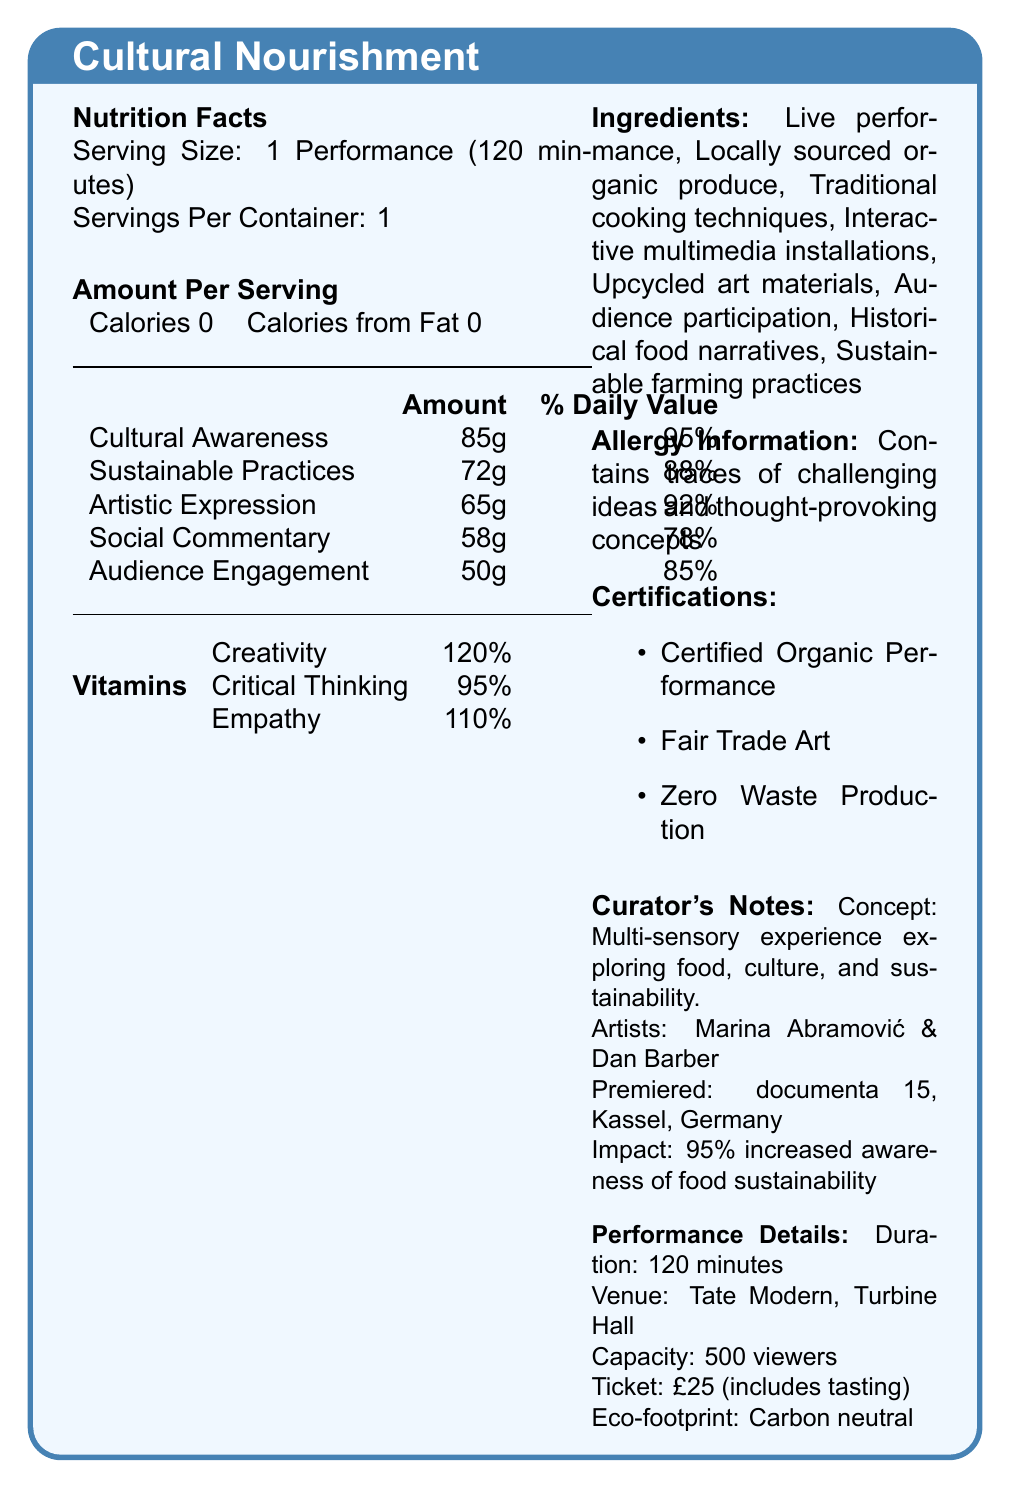what is the serving size? The serving size is specifically mentioned as "1 Performance (120 minutes)" in the document.
Answer: 1 Performance (120 minutes) how many servings are there per container? The document indicates that there is 1 serving per container.
Answer: 1 how many calories are in each serving? Each serving contains 0 calories, as stated in the "Amount Per Serving" section.
Answer: 0 what is the daily value percentage of Cultural Awareness? The daily value percentage of Cultural Awareness is given as 95%.
Answer: 95% which vitamin has the highest daily value percentage? Creativity has the highest daily value percentage at 120%, as listed in the vitamins section.
Answer: Creativity which nutrient contributes the least to the daily value percentage? A. Cultural Awareness B. Social Commentary C. Artistic Expression D. Audience Engagement Social Commentary contributes the least to the daily value percentage with 78%.
Answer: B. Social Commentary what is included in the ticket price? A. Viewing the performance B. Tasting experience C. Behind-the-scenes tour D. Free merchandise The ticket price of £25 includes a tasting experience.
Answer: B. Tasting experience is the performance event carbon neutral? The document specifies that the event is carbon-neutral under the performance details section.
Answer: Yes who are the creators of this performance art piece? The document lists Marina Abramović and Dan Barber as the creators under the curator's notes.
Answer: Marina Abramović and Dan Barber where did the premiere of this performance take place? It is stated in the curator’s notes that the premiere took place at documenta 15 in Kassel, Germany.
Answer: documenta 15, Kassel, Germany what is the primary concept of the performance art piece? The primary concept is mentioned under the curator's notes section.
Answer: Exploring the intricate relationships between food, culture, and sustainability how long is the performance duration? The performance details indicate the duration is 120 minutes.
Answer: 120 minutes what are the main components listed under ingredients? These components make up the listed ingredients in the document.
Answer: Live performance, Locally sourced organic produce, Traditional cooking techniques, Interactive multimedia installations, Upcycled art materials, Audience participation, Historical food narratives, Sustainable farming practices what kind of concepts might the performance contain traces of? The allergy information indicates that the performance contains traces of challenging ideas and thought-provoking concepts.
Answer: Challenging ideas and thought-provoking concepts what percentage of viewers reported increased awareness of food sustainability issues? The curator's notes mention that 95% of viewers reported increased awareness of food sustainability issues.
Answer: 95% what is the venue for the performance? The venue is specified in the performance details section.
Answer: Tate Modern, Turbine Hall describe the allergen information in this performance piece. The allergen information is stated to include traces of challenging ideas and thought-provoking concepts.
Answer: Contains traces of challenging ideas and thought-provoking concepts which certification does NOT apply to this performance? A. Certified Organic Performance B. Fair Trade Art C. Carbon Positive Production D. Zero Waste Production The performance is certified as Certified Organic Performance, Fair Trade Art, and Zero Waste Production. There's no certification for Carbon Positive Production.
Answer: C. Carbon Positive Production which material used in the performance is not biodegradable or recyclable? The document states that all materials used are biodegradable or recyclable, so it's not possible to determine which one is not.
Answer: Cannot be determined summarize the overall idea of the document. The document creatively presents a performance art piece as a Nutritional Facts Label, listing various 'nutrients' and 'vitamins' metaphorically to describe the composition and impact of the performance. It includes detailed curator notes and performance details, emphasizing sustainability and audience engagement.
Answer: The document is a Nutrition Facts Label styled description of a performance art piece titled "Cultural Nourishment" that explores food, culture, and sustainability. The label details components like Cultural Awareness, Sustainable Practices, and Artistic Expression, and includes vitamins such as Creativity and Empathy. Allergy information notes challenging ideas, and certifications highlight its organic and sustainable nature. The performance is created by Marina Abramović and Dan Barber, premiered at documenta 15, and held at Tate Modern. It aims to increase awareness of food sustainability issues, engaging 500 viewers per performance. 